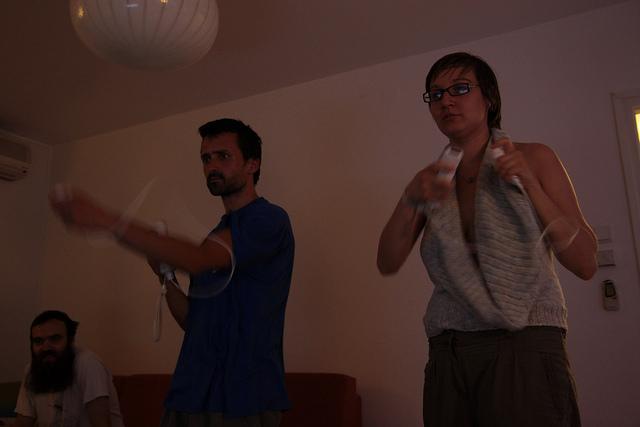What color shirt is she wearing?
Quick response, please. Gray. How many light fixtures are in the picture?
Short answer required. 1. What is the man holding in his hand?
Answer briefly. Wii remote. How many people are in the photo?
Short answer required. 3. Is the sun shining?
Quick response, please. No. What is on the persons left arm?
Short answer required. Wire. What room is this?
Quick response, please. Living room. Are the girl's glasses sitting on the end of her nose?
Quick response, please. No. What is the estimated combined age of the two players?
Be succinct. 50. Does the woman look like she is having a good time?
Short answer required. No. Why does he have two phones?
Write a very short answer. Playing game. Is the woman on the right in a white dress?
Concise answer only. No. What is the man holding?
Answer briefly. Controller. Is the girl smiling?
Short answer required. No. Is the woman wearing a hat?
Write a very short answer. No. How many men are in the bathroom stall?
Short answer required. 0. What are the people doing?
Keep it brief. Playing wii. Does the young man have curly hair?
Keep it brief. No. Are the people playing a video game?
Keep it brief. Yes. Is there a picture on the wall?
Answer briefly. No. What is the man in the picture holding in his right hand?
Keep it brief. Wii controller. Are all the men holding Wii remote?
Concise answer only. Yes. Are they going to a formal occasion?
Answer briefly. No. Is the man having a good time?
Concise answer only. Yes. What's the color of the lady's hair?
Write a very short answer. Brown. Is the man wearing a tie?
Write a very short answer. No. What gender is the person in the scene?
Answer briefly. Male and female. Are they dressed for a formal occasion?
Be succinct. No. Where are the glasses?
Keep it brief. On her face. Is there a round vegetable that matches this sweater?
Be succinct. No. Is this a color picture?
Be succinct. Yes. What color is the woman's vest?
Keep it brief. Gray. Is he wearing a hat?
Keep it brief. No. Is the light on or off?
Short answer required. Off. Is there a crowd?
Write a very short answer. No. Is this a  modern photo?
Be succinct. Yes. Are they at a restaurant?
Answer briefly. No. Is everyone holding a device?
Quick response, please. Yes. Are there pictures on the wall?
Short answer required. No. What type of shirt is the man wearing?
Short answer required. T shirt. How many men are in this picture?
Short answer required. 2. Are they getting ready for bed?
Quick response, please. No. Which one of the two is wearing glasses?
Keep it brief. Woman. Is this black and white?
Be succinct. No. What is the woman standing wearing?
Be succinct. Sweater. Is the person male or female?
Concise answer only. Male. Which person is wearing glasses?
Quick response, please. Woman. Has the man recently shaved?
Keep it brief. No. Is the woman wearing glasses?
Short answer required. Yes. Is the man wearing a wedding ring?
Be succinct. No. Is the woman shorter than the man?
Answer briefly. No. What color is the wall to the left?
Short answer required. White. What are these people holding?
Write a very short answer. Wii remotes. Is it night time?
Keep it brief. Yes. Is the man all dressed up?
Answer briefly. No. Is there any art on the wall?
Answer briefly. No. What is the man holding in his hands?
Keep it brief. Wii remote. Are the people baking?
Quick response, please. No. What is in back of the couple?
Be succinct. Wall. What color is the man's top?
Give a very brief answer. Blue. Is the woman happy?
Give a very brief answer. No. What is the woman holding in her left hand?
Keep it brief. Wii remote. What color is the ceiling?
Answer briefly. White. Which person is taller?
Concise answer only. Woman. Are the lights on?
Quick response, please. No. What is the primary color of the boy's socks?
Keep it brief. White. What is the boy holding?
Answer briefly. Controller. Is there a wreath hanging on the wall?
Write a very short answer. No. How many people are shown?
Keep it brief. 3. What does the boy have on his head?
Short answer required. Hair. What is he holding?
Short answer required. Wii controller. Is one of them standing on a stool?
Quick response, please. No. What color clothing are these men wearing?
Be succinct. Blue. Where could this photo be taken?
Short answer required. Living room. What is the color of the man's shirt?
Keep it brief. Blue. Is the woman wearing an apron?
Keep it brief. No. What is the man standing next to?
Keep it brief. Couch. Is this girl looking for food?
Short answer required. No. What do both of them have in their right hand?
Keep it brief. Wii remote. Does this look like a recently taken picture?
Write a very short answer. Yes. What color is the man's shirt on the left?
Be succinct. Blue. How long is the girl's hair?
Keep it brief. Short. 